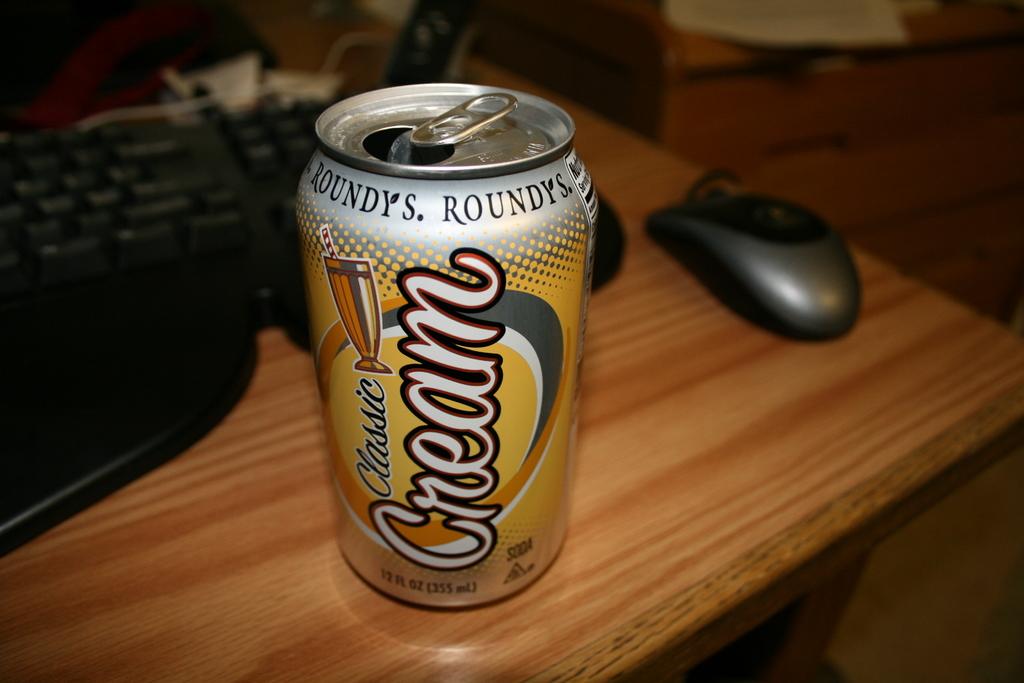What type of soda is this?
Provide a succinct answer. Cream. How many ml's are in this can?
Your response must be concise. 355. 